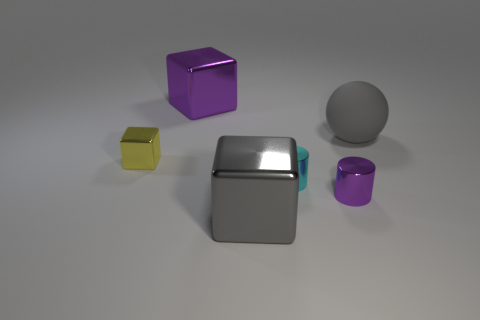Add 1 rubber cylinders. How many objects exist? 7 Subtract all cylinders. How many objects are left? 4 Add 2 big purple cubes. How many big purple cubes exist? 3 Subtract 0 blue cylinders. How many objects are left? 6 Subtract all small cyan matte balls. Subtract all matte spheres. How many objects are left? 5 Add 6 yellow objects. How many yellow objects are left? 7 